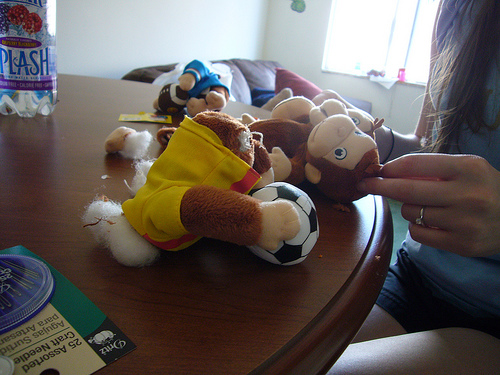<image>
Is there a doll to the left of the doll? No. The doll is not to the left of the doll. From this viewpoint, they have a different horizontal relationship. 